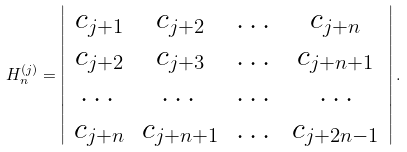Convert formula to latex. <formula><loc_0><loc_0><loc_500><loc_500>H _ { n } ^ { ( j ) } = \left | \begin{array} { c c c c } c _ { j + 1 } & c _ { j + 2 } & \dots & c _ { j + n } \\ c _ { j + 2 } & c _ { j + 3 } & \dots & c _ { j + n + 1 } \\ \dots & \dots & \dots & \dots \\ c _ { j + n } & c _ { j + n + 1 } & \dots & c _ { j + 2 n - 1 } \end{array} \right | .</formula> 